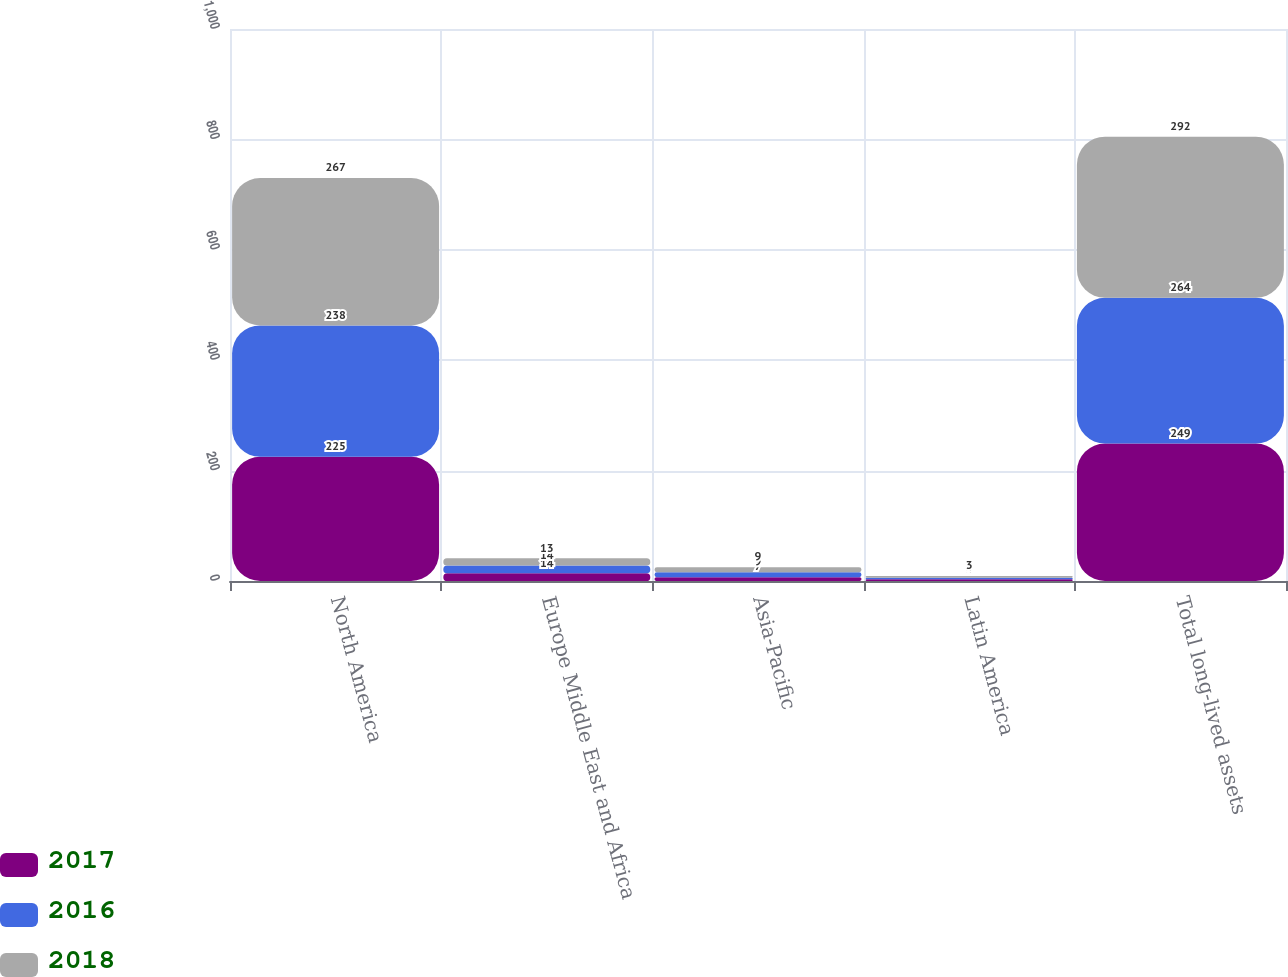Convert chart. <chart><loc_0><loc_0><loc_500><loc_500><stacked_bar_chart><ecel><fcel>North America<fcel>Europe Middle East and Africa<fcel>Asia-Pacific<fcel>Latin America<fcel>Total long-lived assets<nl><fcel>2017<fcel>225<fcel>14<fcel>7<fcel>3<fcel>249<nl><fcel>2016<fcel>238<fcel>14<fcel>9<fcel>3<fcel>264<nl><fcel>2018<fcel>267<fcel>13<fcel>9<fcel>3<fcel>292<nl></chart> 